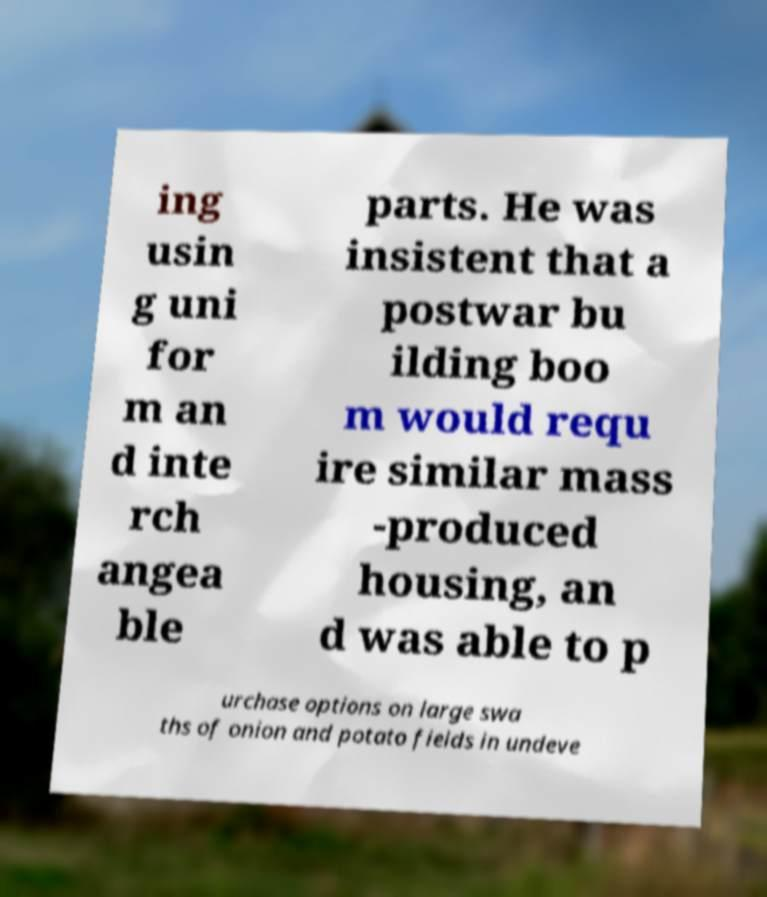Please read and relay the text visible in this image. What does it say? ing usin g uni for m an d inte rch angea ble parts. He was insistent that a postwar bu ilding boo m would requ ire similar mass -produced housing, an d was able to p urchase options on large swa ths of onion and potato fields in undeve 